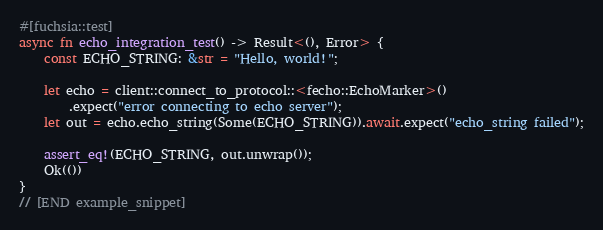<code> <loc_0><loc_0><loc_500><loc_500><_Rust_>
#[fuchsia::test]
async fn echo_integration_test() -> Result<(), Error> {
    const ECHO_STRING: &str = "Hello, world!";

    let echo = client::connect_to_protocol::<fecho::EchoMarker>()
        .expect("error connecting to echo server");
    let out = echo.echo_string(Some(ECHO_STRING)).await.expect("echo_string failed");

    assert_eq!(ECHO_STRING, out.unwrap());
    Ok(())
}
// [END example_snippet]
</code> 